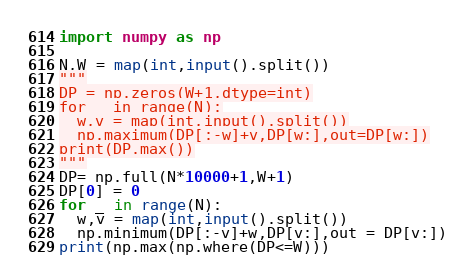<code> <loc_0><loc_0><loc_500><loc_500><_Python_>import numpy as np

N,W = map(int,input().split())
"""
DP = np.zeros(W+1,dtype=int)
for _ in range(N):
  w,v = map(int,input().split())
  np.maximum(DP[:-w]+v,DP[w:],out=DP[w:])
print(DP.max())
"""
DP= np.full(N*10000+1,W+1)
DP[0] = 0
for _ in range(N):
  w,v = map(int,input().split())
  np.minimum(DP[:-v]+w,DP[v:],out = DP[v:])
print(np.max(np.where(DP<=W)))</code> 